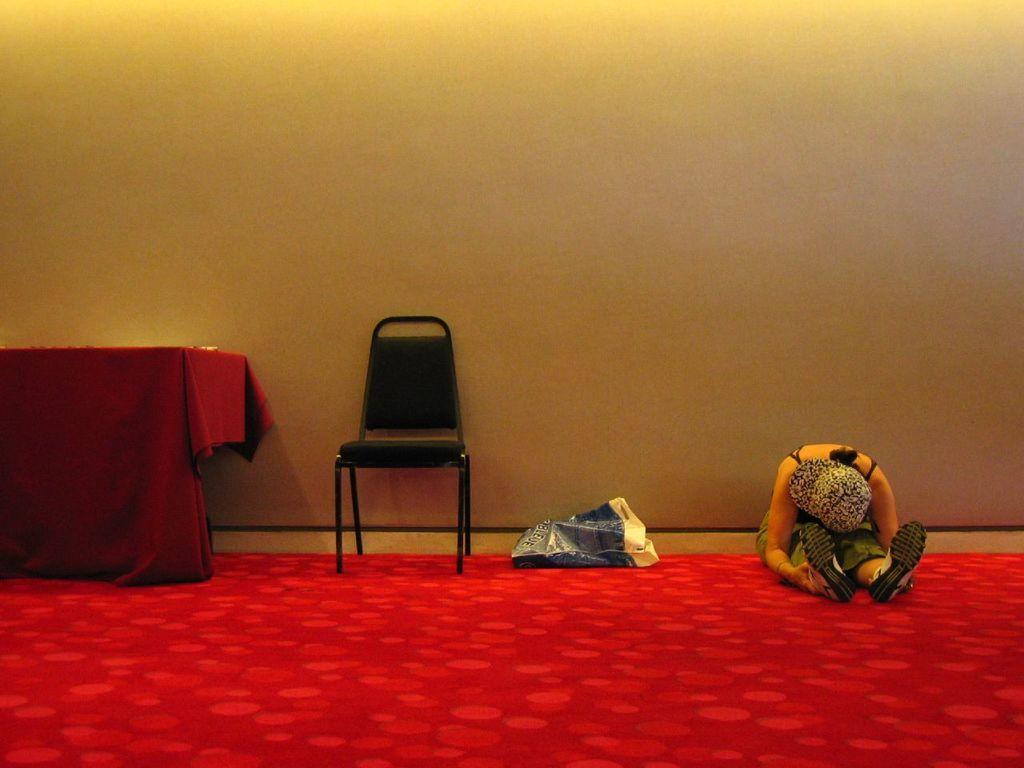Could you give a brief overview of what you see in this image? In this image we can see a woman is sitting on the red color carpet, at beside here is the chair, here is the table and cloth on it, here is the wall. 